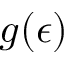Convert formula to latex. <formula><loc_0><loc_0><loc_500><loc_500>g ( \epsilon )</formula> 